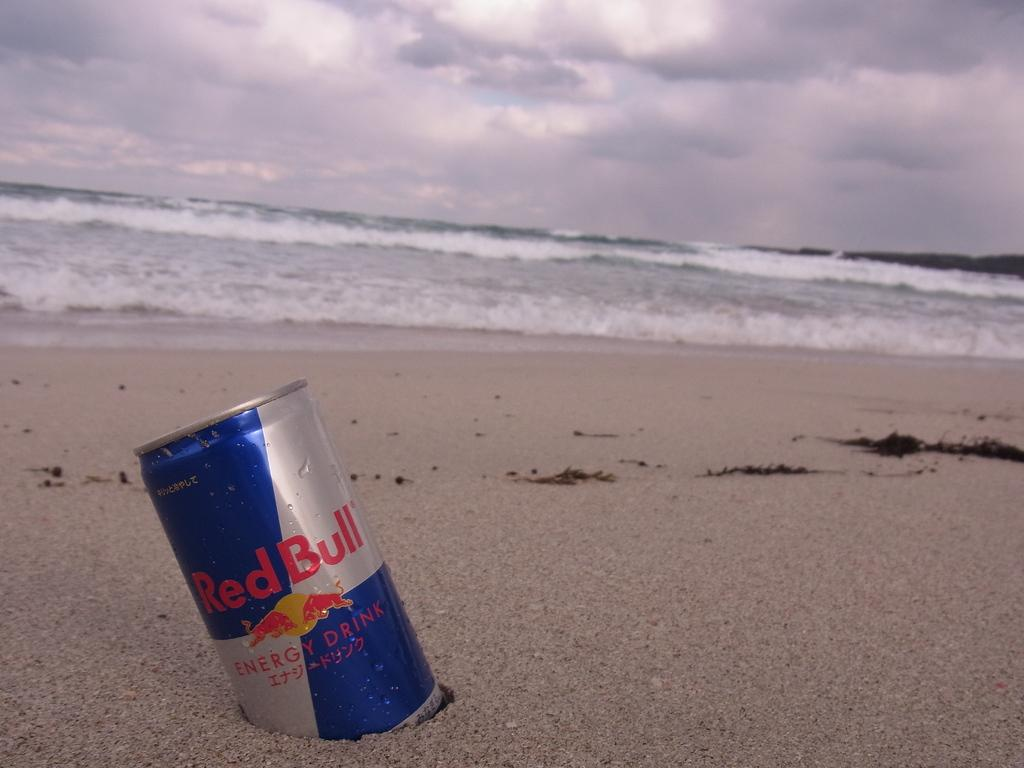Provide a one-sentence caption for the provided image. A can of Red Bull energy drink is sitting in the sand on a stormy beach. 